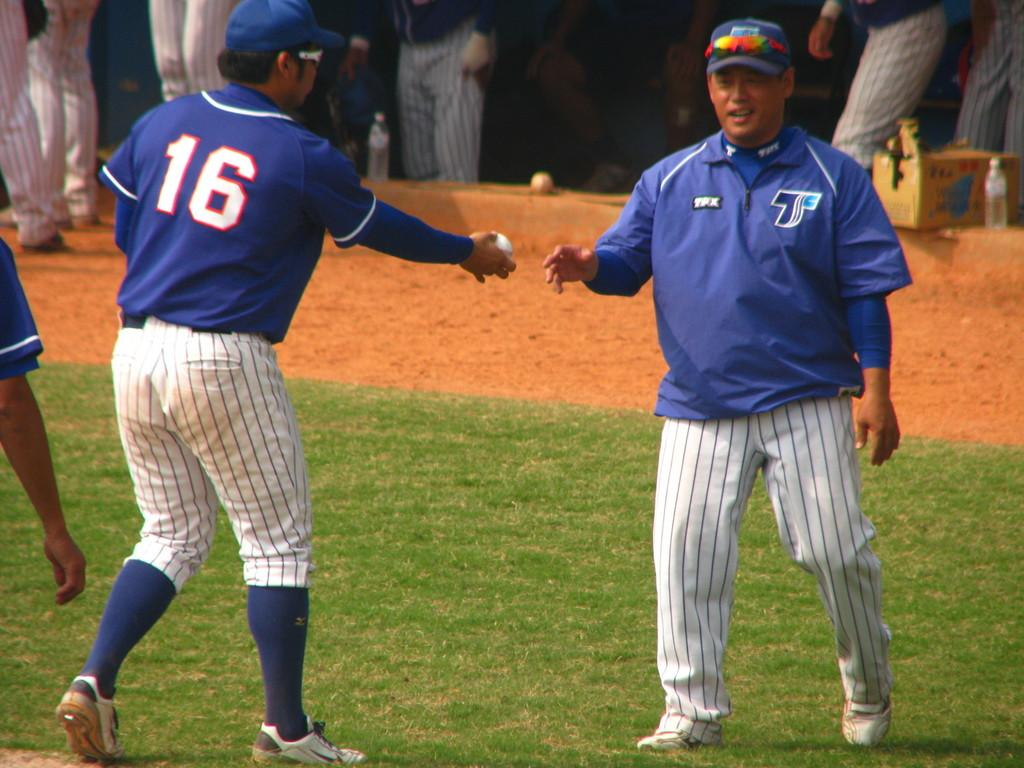<image>
Render a clear and concise summary of the photo. Player number 16 reaches out to hand the coach a ball. 